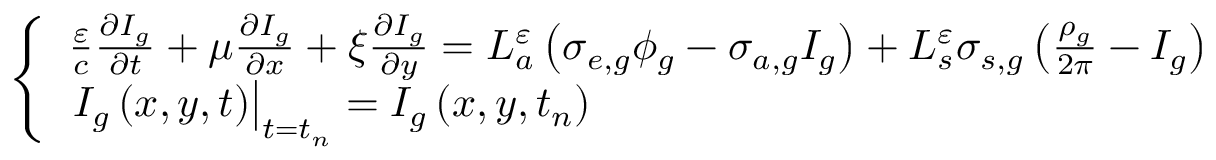<formula> <loc_0><loc_0><loc_500><loc_500>\left \{ \begin{array} { l } { { \frac { \varepsilon } { c } \frac { \partial I _ { g } } { \partial t } + \mu \frac { \partial I _ { g } } { \partial x } + \xi \frac { \partial I _ { g } } { \partial y } = L _ { a } ^ { \varepsilon } \left ( \sigma _ { e , g } \phi _ { g } - \sigma _ { a , g } I _ { g } \right ) + L _ { s } ^ { \varepsilon } \sigma _ { s , g } \left ( \frac { \rho _ { g } } { 2 \pi } - I _ { g } \right ) } } \\ { { I _ { g } \left ( x , y , t \right ) \right | _ { t = t _ { n } } = I _ { g } \left ( x , y , t _ { n } \right ) } } \end{array}</formula> 